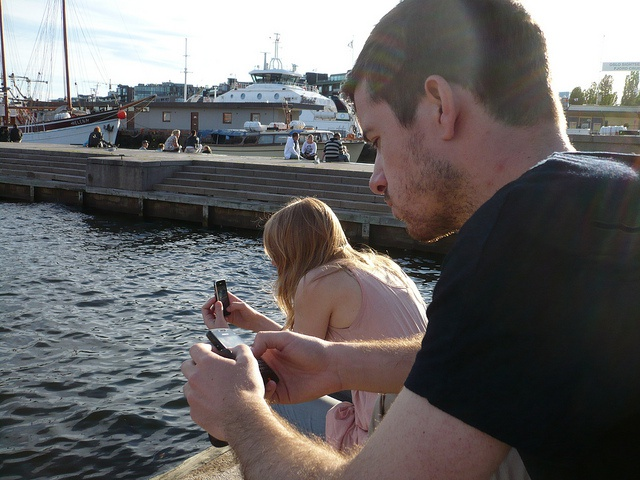Describe the objects in this image and their specific colors. I can see people in salmon, black, gray, and maroon tones, people in salmon, gray, maroon, and black tones, boat in salmon, gray, black, and darkgray tones, boat in salmon, white, gray, and black tones, and cell phone in salmon, black, lightgray, and darkgray tones in this image. 